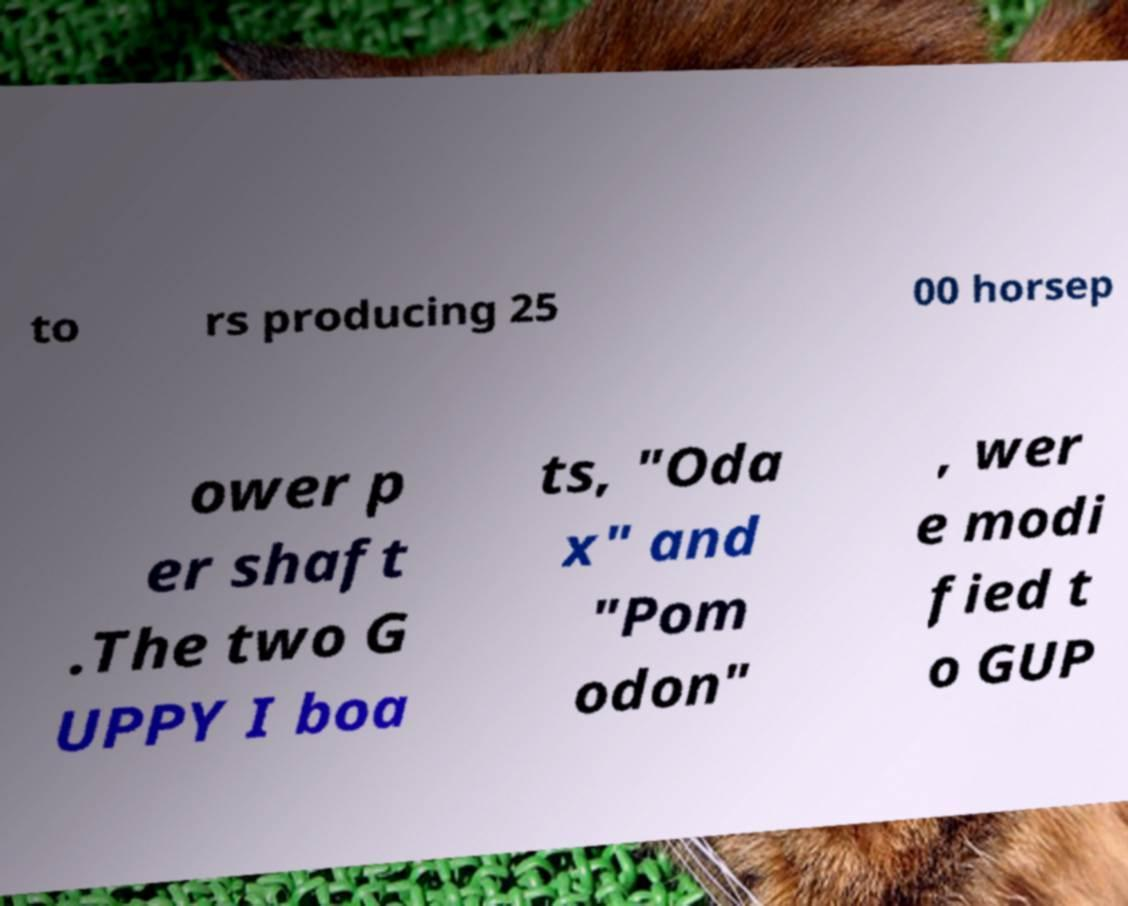Could you extract and type out the text from this image? to rs producing 25 00 horsep ower p er shaft .The two G UPPY I boa ts, "Oda x" and "Pom odon" , wer e modi fied t o GUP 